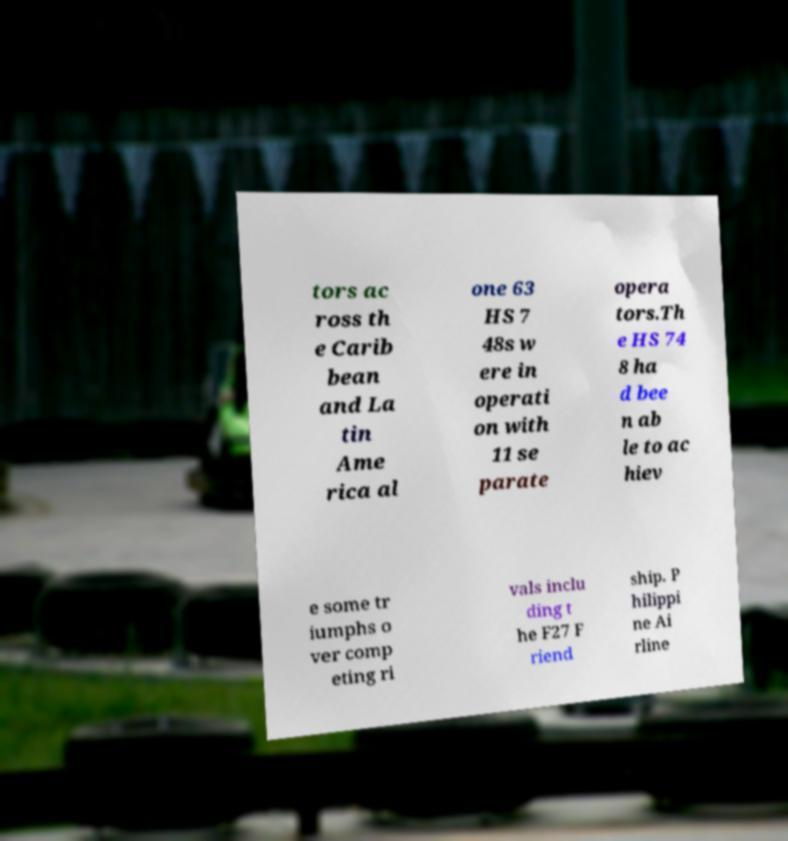Could you extract and type out the text from this image? tors ac ross th e Carib bean and La tin Ame rica al one 63 HS 7 48s w ere in operati on with 11 se parate opera tors.Th e HS 74 8 ha d bee n ab le to ac hiev e some tr iumphs o ver comp eting ri vals inclu ding t he F27 F riend ship. P hilippi ne Ai rline 